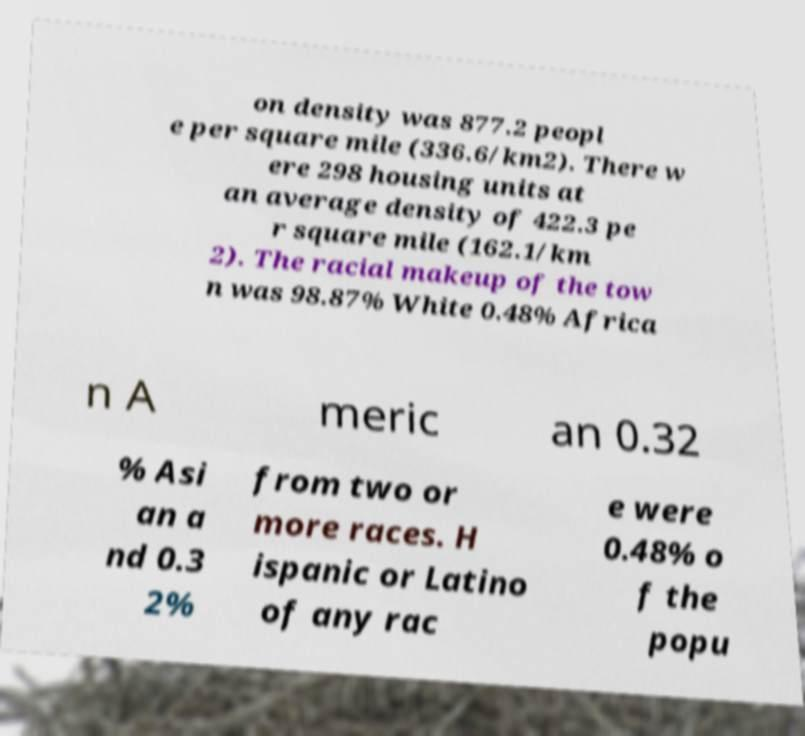Please identify and transcribe the text found in this image. on density was 877.2 peopl e per square mile (336.6/km2). There w ere 298 housing units at an average density of 422.3 pe r square mile (162.1/km 2). The racial makeup of the tow n was 98.87% White 0.48% Africa n A meric an 0.32 % Asi an a nd 0.3 2% from two or more races. H ispanic or Latino of any rac e were 0.48% o f the popu 